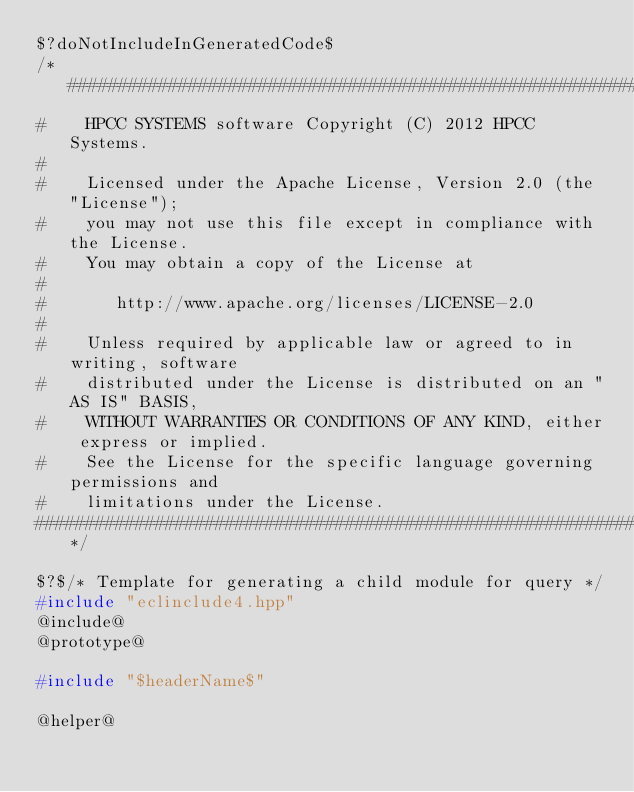Convert code to text. <code><loc_0><loc_0><loc_500><loc_500><_C++_>$?doNotIncludeInGeneratedCode$
/*##############################################################################
#    HPCC SYSTEMS software Copyright (C) 2012 HPCC Systems.
#
#    Licensed under the Apache License, Version 2.0 (the "License");
#    you may not use this file except in compliance with the License.
#    You may obtain a copy of the License at
#
#       http://www.apache.org/licenses/LICENSE-2.0
#
#    Unless required by applicable law or agreed to in writing, software
#    distributed under the License is distributed on an "AS IS" BASIS,
#    WITHOUT WARRANTIES OR CONDITIONS OF ANY KIND, either express or implied.
#    See the License for the specific language governing permissions and
#    limitations under the License.
##############################################################################*/

$?$/* Template for generating a child module for query */
#include "eclinclude4.hpp"
@include@
@prototype@

#include "$headerName$"

@helper@
</code> 